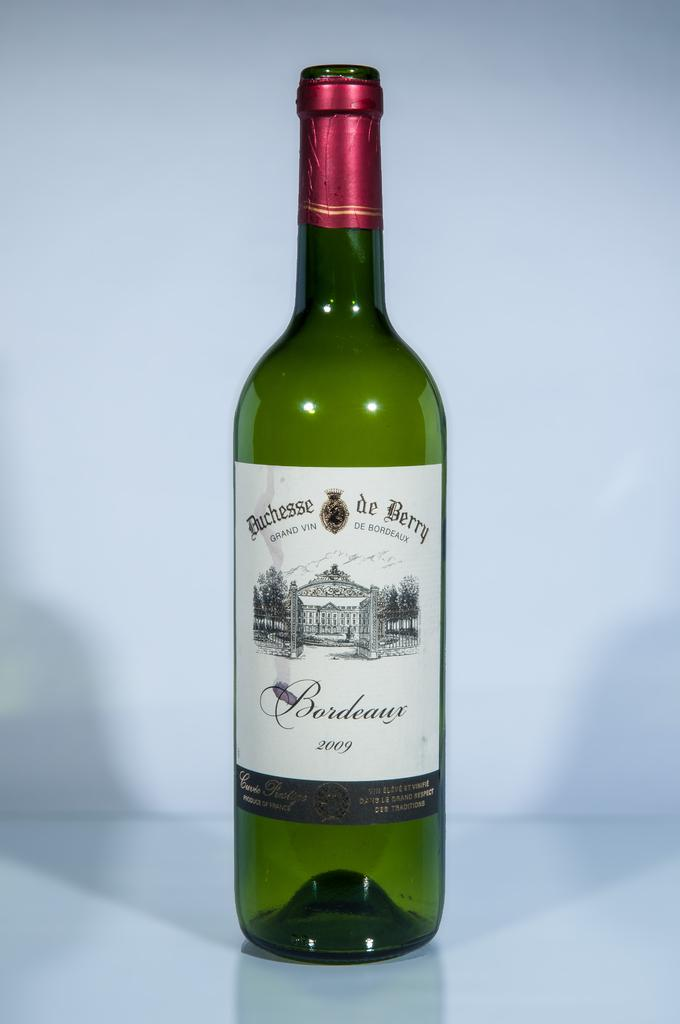<image>
Provide a brief description of the given image. A bottle of Duchesse de Berry Bordeaux is on a white counter. 